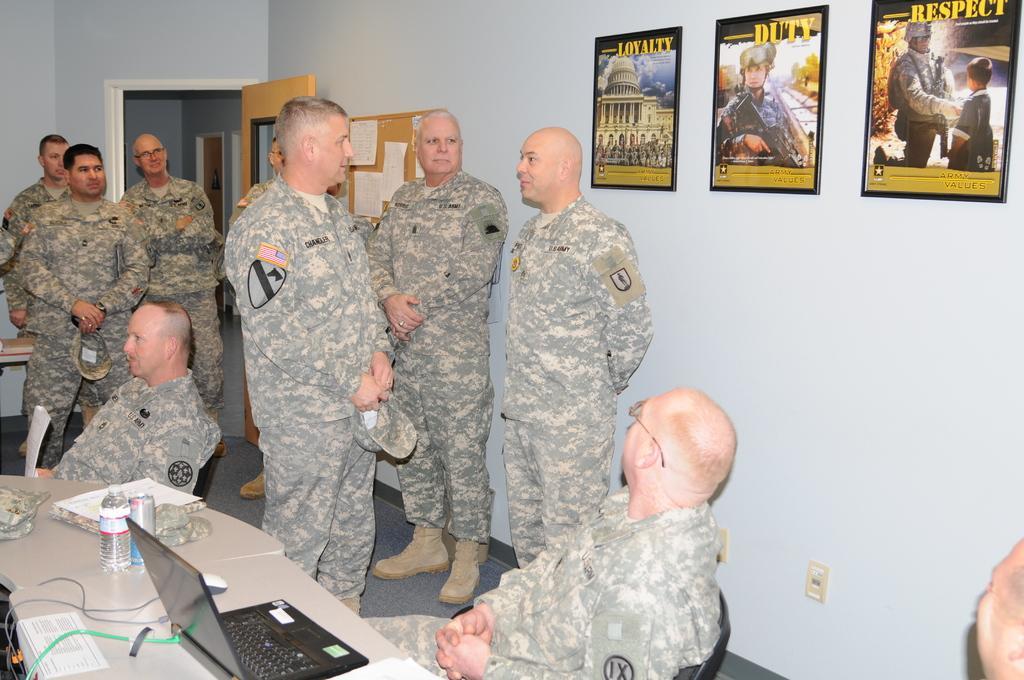Please provide a concise description of this image. There are many people. Some are sitting and some are standing. There are tables. On the tables there are caps, laptop, mouse, bottles and many other things. In the back there is a wall with photo frames and a board with notices. Also there is a door. 